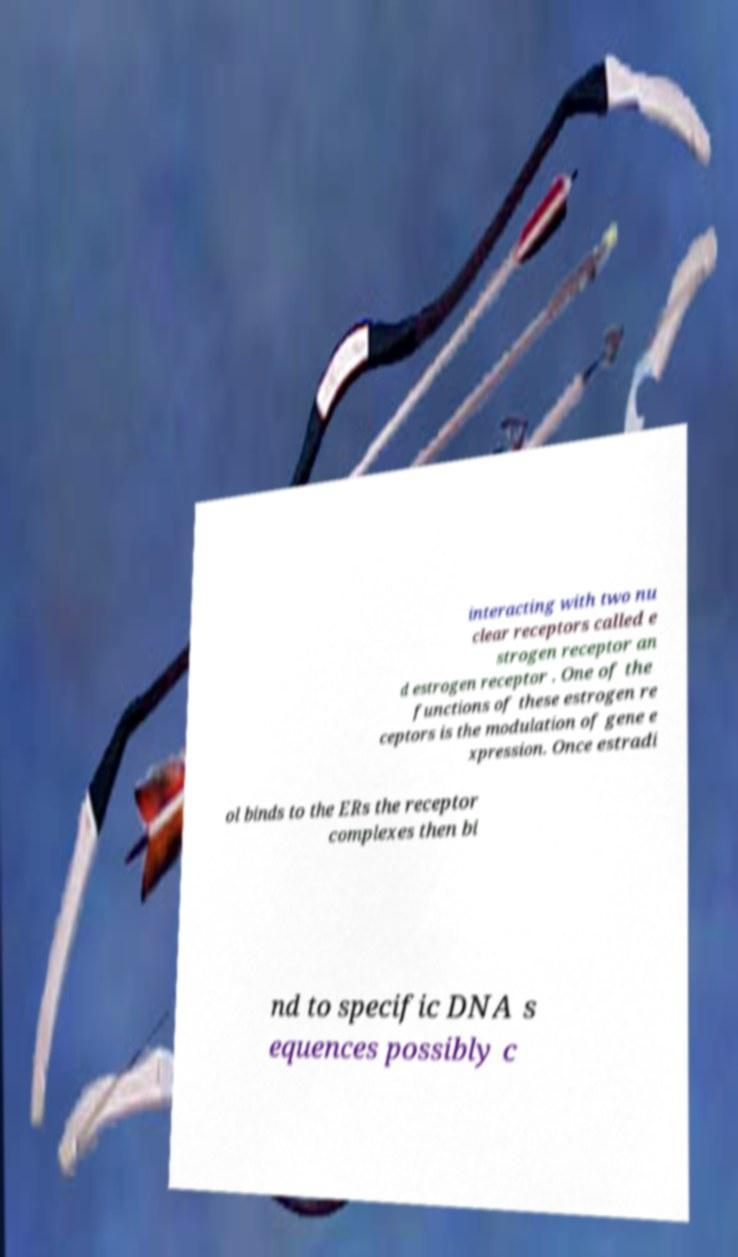There's text embedded in this image that I need extracted. Can you transcribe it verbatim? interacting with two nu clear receptors called e strogen receptor an d estrogen receptor . One of the functions of these estrogen re ceptors is the modulation of gene e xpression. Once estradi ol binds to the ERs the receptor complexes then bi nd to specific DNA s equences possibly c 